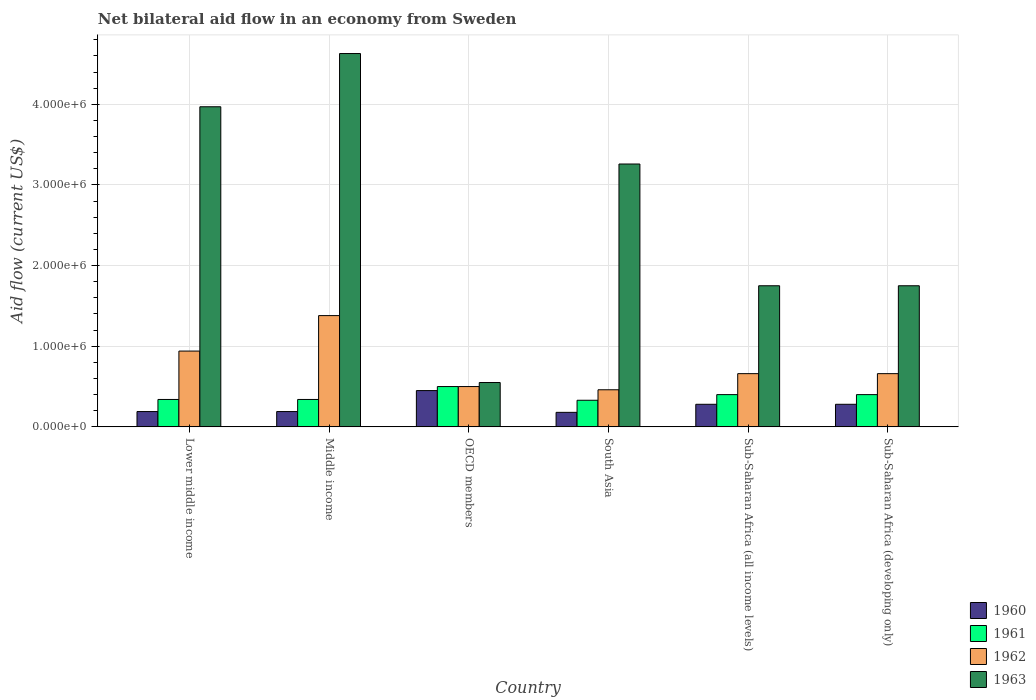How many different coloured bars are there?
Ensure brevity in your answer.  4. How many groups of bars are there?
Ensure brevity in your answer.  6. How many bars are there on the 2nd tick from the left?
Offer a terse response. 4. How many bars are there on the 3rd tick from the right?
Your answer should be compact. 4. What is the label of the 5th group of bars from the left?
Your answer should be compact. Sub-Saharan Africa (all income levels). Across all countries, what is the maximum net bilateral aid flow in 1961?
Make the answer very short. 5.00e+05. In which country was the net bilateral aid flow in 1960 maximum?
Your answer should be very brief. OECD members. What is the total net bilateral aid flow in 1963 in the graph?
Give a very brief answer. 1.59e+07. What is the difference between the net bilateral aid flow in 1962 in South Asia and that in Sub-Saharan Africa (developing only)?
Keep it short and to the point. -2.00e+05. What is the difference between the net bilateral aid flow in 1960 in Sub-Saharan Africa (developing only) and the net bilateral aid flow in 1961 in South Asia?
Ensure brevity in your answer.  -5.00e+04. What is the average net bilateral aid flow in 1962 per country?
Provide a short and direct response. 7.67e+05. What is the difference between the net bilateral aid flow of/in 1963 and net bilateral aid flow of/in 1962 in Sub-Saharan Africa (developing only)?
Keep it short and to the point. 1.09e+06. In how many countries, is the net bilateral aid flow in 1963 greater than 4200000 US$?
Give a very brief answer. 1. What is the ratio of the net bilateral aid flow in 1963 in South Asia to that in Sub-Saharan Africa (developing only)?
Your answer should be very brief. 1.86. Is the net bilateral aid flow in 1960 in Lower middle income less than that in Sub-Saharan Africa (developing only)?
Give a very brief answer. Yes. Is the difference between the net bilateral aid flow in 1963 in South Asia and Sub-Saharan Africa (developing only) greater than the difference between the net bilateral aid flow in 1962 in South Asia and Sub-Saharan Africa (developing only)?
Give a very brief answer. Yes. What is the difference between the highest and the second highest net bilateral aid flow in 1960?
Keep it short and to the point. 1.70e+05. What does the 3rd bar from the left in Lower middle income represents?
Your answer should be compact. 1962. Is it the case that in every country, the sum of the net bilateral aid flow in 1960 and net bilateral aid flow in 1963 is greater than the net bilateral aid flow in 1962?
Offer a terse response. Yes. How many bars are there?
Ensure brevity in your answer.  24. Are all the bars in the graph horizontal?
Ensure brevity in your answer.  No. Does the graph contain any zero values?
Your answer should be very brief. No. Does the graph contain grids?
Your answer should be very brief. Yes. How are the legend labels stacked?
Give a very brief answer. Vertical. What is the title of the graph?
Provide a succinct answer. Net bilateral aid flow in an economy from Sweden. Does "1982" appear as one of the legend labels in the graph?
Give a very brief answer. No. What is the Aid flow (current US$) in 1962 in Lower middle income?
Give a very brief answer. 9.40e+05. What is the Aid flow (current US$) in 1963 in Lower middle income?
Offer a terse response. 3.97e+06. What is the Aid flow (current US$) of 1960 in Middle income?
Provide a succinct answer. 1.90e+05. What is the Aid flow (current US$) in 1962 in Middle income?
Ensure brevity in your answer.  1.38e+06. What is the Aid flow (current US$) of 1963 in Middle income?
Provide a short and direct response. 4.63e+06. What is the Aid flow (current US$) of 1960 in OECD members?
Your answer should be compact. 4.50e+05. What is the Aid flow (current US$) in 1961 in OECD members?
Your response must be concise. 5.00e+05. What is the Aid flow (current US$) of 1963 in OECD members?
Your answer should be compact. 5.50e+05. What is the Aid flow (current US$) in 1960 in South Asia?
Your answer should be very brief. 1.80e+05. What is the Aid flow (current US$) in 1963 in South Asia?
Offer a terse response. 3.26e+06. What is the Aid flow (current US$) of 1962 in Sub-Saharan Africa (all income levels)?
Offer a very short reply. 6.60e+05. What is the Aid flow (current US$) of 1963 in Sub-Saharan Africa (all income levels)?
Give a very brief answer. 1.75e+06. What is the Aid flow (current US$) of 1961 in Sub-Saharan Africa (developing only)?
Ensure brevity in your answer.  4.00e+05. What is the Aid flow (current US$) of 1963 in Sub-Saharan Africa (developing only)?
Provide a succinct answer. 1.75e+06. Across all countries, what is the maximum Aid flow (current US$) of 1962?
Offer a terse response. 1.38e+06. Across all countries, what is the maximum Aid flow (current US$) in 1963?
Keep it short and to the point. 4.63e+06. Across all countries, what is the minimum Aid flow (current US$) in 1963?
Ensure brevity in your answer.  5.50e+05. What is the total Aid flow (current US$) of 1960 in the graph?
Provide a short and direct response. 1.57e+06. What is the total Aid flow (current US$) of 1961 in the graph?
Give a very brief answer. 2.31e+06. What is the total Aid flow (current US$) in 1962 in the graph?
Your answer should be compact. 4.60e+06. What is the total Aid flow (current US$) of 1963 in the graph?
Give a very brief answer. 1.59e+07. What is the difference between the Aid flow (current US$) of 1962 in Lower middle income and that in Middle income?
Give a very brief answer. -4.40e+05. What is the difference between the Aid flow (current US$) in 1963 in Lower middle income and that in Middle income?
Ensure brevity in your answer.  -6.60e+05. What is the difference between the Aid flow (current US$) of 1963 in Lower middle income and that in OECD members?
Provide a succinct answer. 3.42e+06. What is the difference between the Aid flow (current US$) in 1962 in Lower middle income and that in South Asia?
Provide a short and direct response. 4.80e+05. What is the difference between the Aid flow (current US$) of 1963 in Lower middle income and that in South Asia?
Give a very brief answer. 7.10e+05. What is the difference between the Aid flow (current US$) of 1961 in Lower middle income and that in Sub-Saharan Africa (all income levels)?
Your answer should be very brief. -6.00e+04. What is the difference between the Aid flow (current US$) in 1963 in Lower middle income and that in Sub-Saharan Africa (all income levels)?
Offer a terse response. 2.22e+06. What is the difference between the Aid flow (current US$) in 1960 in Lower middle income and that in Sub-Saharan Africa (developing only)?
Ensure brevity in your answer.  -9.00e+04. What is the difference between the Aid flow (current US$) of 1963 in Lower middle income and that in Sub-Saharan Africa (developing only)?
Ensure brevity in your answer.  2.22e+06. What is the difference between the Aid flow (current US$) in 1961 in Middle income and that in OECD members?
Ensure brevity in your answer.  -1.60e+05. What is the difference between the Aid flow (current US$) in 1962 in Middle income and that in OECD members?
Your response must be concise. 8.80e+05. What is the difference between the Aid flow (current US$) of 1963 in Middle income and that in OECD members?
Keep it short and to the point. 4.08e+06. What is the difference between the Aid flow (current US$) in 1962 in Middle income and that in South Asia?
Make the answer very short. 9.20e+05. What is the difference between the Aid flow (current US$) in 1963 in Middle income and that in South Asia?
Offer a very short reply. 1.37e+06. What is the difference between the Aid flow (current US$) in 1960 in Middle income and that in Sub-Saharan Africa (all income levels)?
Give a very brief answer. -9.00e+04. What is the difference between the Aid flow (current US$) of 1962 in Middle income and that in Sub-Saharan Africa (all income levels)?
Ensure brevity in your answer.  7.20e+05. What is the difference between the Aid flow (current US$) of 1963 in Middle income and that in Sub-Saharan Africa (all income levels)?
Your answer should be compact. 2.88e+06. What is the difference between the Aid flow (current US$) of 1960 in Middle income and that in Sub-Saharan Africa (developing only)?
Your answer should be very brief. -9.00e+04. What is the difference between the Aid flow (current US$) in 1961 in Middle income and that in Sub-Saharan Africa (developing only)?
Your answer should be compact. -6.00e+04. What is the difference between the Aid flow (current US$) of 1962 in Middle income and that in Sub-Saharan Africa (developing only)?
Keep it short and to the point. 7.20e+05. What is the difference between the Aid flow (current US$) of 1963 in Middle income and that in Sub-Saharan Africa (developing only)?
Provide a short and direct response. 2.88e+06. What is the difference between the Aid flow (current US$) in 1960 in OECD members and that in South Asia?
Keep it short and to the point. 2.70e+05. What is the difference between the Aid flow (current US$) of 1962 in OECD members and that in South Asia?
Your answer should be compact. 4.00e+04. What is the difference between the Aid flow (current US$) of 1963 in OECD members and that in South Asia?
Keep it short and to the point. -2.71e+06. What is the difference between the Aid flow (current US$) in 1961 in OECD members and that in Sub-Saharan Africa (all income levels)?
Provide a short and direct response. 1.00e+05. What is the difference between the Aid flow (current US$) in 1962 in OECD members and that in Sub-Saharan Africa (all income levels)?
Offer a terse response. -1.60e+05. What is the difference between the Aid flow (current US$) in 1963 in OECD members and that in Sub-Saharan Africa (all income levels)?
Ensure brevity in your answer.  -1.20e+06. What is the difference between the Aid flow (current US$) in 1960 in OECD members and that in Sub-Saharan Africa (developing only)?
Keep it short and to the point. 1.70e+05. What is the difference between the Aid flow (current US$) in 1962 in OECD members and that in Sub-Saharan Africa (developing only)?
Make the answer very short. -1.60e+05. What is the difference between the Aid flow (current US$) in 1963 in OECD members and that in Sub-Saharan Africa (developing only)?
Make the answer very short. -1.20e+06. What is the difference between the Aid flow (current US$) in 1961 in South Asia and that in Sub-Saharan Africa (all income levels)?
Offer a very short reply. -7.00e+04. What is the difference between the Aid flow (current US$) in 1962 in South Asia and that in Sub-Saharan Africa (all income levels)?
Ensure brevity in your answer.  -2.00e+05. What is the difference between the Aid flow (current US$) of 1963 in South Asia and that in Sub-Saharan Africa (all income levels)?
Give a very brief answer. 1.51e+06. What is the difference between the Aid flow (current US$) of 1960 in South Asia and that in Sub-Saharan Africa (developing only)?
Provide a short and direct response. -1.00e+05. What is the difference between the Aid flow (current US$) in 1961 in South Asia and that in Sub-Saharan Africa (developing only)?
Ensure brevity in your answer.  -7.00e+04. What is the difference between the Aid flow (current US$) in 1963 in South Asia and that in Sub-Saharan Africa (developing only)?
Your answer should be very brief. 1.51e+06. What is the difference between the Aid flow (current US$) of 1960 in Sub-Saharan Africa (all income levels) and that in Sub-Saharan Africa (developing only)?
Provide a short and direct response. 0. What is the difference between the Aid flow (current US$) of 1962 in Sub-Saharan Africa (all income levels) and that in Sub-Saharan Africa (developing only)?
Offer a terse response. 0. What is the difference between the Aid flow (current US$) in 1963 in Sub-Saharan Africa (all income levels) and that in Sub-Saharan Africa (developing only)?
Ensure brevity in your answer.  0. What is the difference between the Aid flow (current US$) in 1960 in Lower middle income and the Aid flow (current US$) in 1962 in Middle income?
Your answer should be compact. -1.19e+06. What is the difference between the Aid flow (current US$) in 1960 in Lower middle income and the Aid flow (current US$) in 1963 in Middle income?
Provide a short and direct response. -4.44e+06. What is the difference between the Aid flow (current US$) of 1961 in Lower middle income and the Aid flow (current US$) of 1962 in Middle income?
Make the answer very short. -1.04e+06. What is the difference between the Aid flow (current US$) in 1961 in Lower middle income and the Aid flow (current US$) in 1963 in Middle income?
Offer a terse response. -4.29e+06. What is the difference between the Aid flow (current US$) of 1962 in Lower middle income and the Aid flow (current US$) of 1963 in Middle income?
Provide a short and direct response. -3.69e+06. What is the difference between the Aid flow (current US$) in 1960 in Lower middle income and the Aid flow (current US$) in 1961 in OECD members?
Provide a succinct answer. -3.10e+05. What is the difference between the Aid flow (current US$) in 1960 in Lower middle income and the Aid flow (current US$) in 1962 in OECD members?
Make the answer very short. -3.10e+05. What is the difference between the Aid flow (current US$) in 1960 in Lower middle income and the Aid flow (current US$) in 1963 in OECD members?
Your answer should be compact. -3.60e+05. What is the difference between the Aid flow (current US$) of 1961 in Lower middle income and the Aid flow (current US$) of 1962 in OECD members?
Give a very brief answer. -1.60e+05. What is the difference between the Aid flow (current US$) of 1962 in Lower middle income and the Aid flow (current US$) of 1963 in OECD members?
Your answer should be very brief. 3.90e+05. What is the difference between the Aid flow (current US$) of 1960 in Lower middle income and the Aid flow (current US$) of 1961 in South Asia?
Make the answer very short. -1.40e+05. What is the difference between the Aid flow (current US$) in 1960 in Lower middle income and the Aid flow (current US$) in 1963 in South Asia?
Your response must be concise. -3.07e+06. What is the difference between the Aid flow (current US$) of 1961 in Lower middle income and the Aid flow (current US$) of 1962 in South Asia?
Provide a succinct answer. -1.20e+05. What is the difference between the Aid flow (current US$) in 1961 in Lower middle income and the Aid flow (current US$) in 1963 in South Asia?
Make the answer very short. -2.92e+06. What is the difference between the Aid flow (current US$) in 1962 in Lower middle income and the Aid flow (current US$) in 1963 in South Asia?
Your answer should be very brief. -2.32e+06. What is the difference between the Aid flow (current US$) of 1960 in Lower middle income and the Aid flow (current US$) of 1961 in Sub-Saharan Africa (all income levels)?
Offer a terse response. -2.10e+05. What is the difference between the Aid flow (current US$) in 1960 in Lower middle income and the Aid flow (current US$) in 1962 in Sub-Saharan Africa (all income levels)?
Provide a succinct answer. -4.70e+05. What is the difference between the Aid flow (current US$) of 1960 in Lower middle income and the Aid flow (current US$) of 1963 in Sub-Saharan Africa (all income levels)?
Give a very brief answer. -1.56e+06. What is the difference between the Aid flow (current US$) in 1961 in Lower middle income and the Aid flow (current US$) in 1962 in Sub-Saharan Africa (all income levels)?
Your answer should be very brief. -3.20e+05. What is the difference between the Aid flow (current US$) in 1961 in Lower middle income and the Aid flow (current US$) in 1963 in Sub-Saharan Africa (all income levels)?
Your answer should be compact. -1.41e+06. What is the difference between the Aid flow (current US$) in 1962 in Lower middle income and the Aid flow (current US$) in 1963 in Sub-Saharan Africa (all income levels)?
Keep it short and to the point. -8.10e+05. What is the difference between the Aid flow (current US$) of 1960 in Lower middle income and the Aid flow (current US$) of 1961 in Sub-Saharan Africa (developing only)?
Ensure brevity in your answer.  -2.10e+05. What is the difference between the Aid flow (current US$) in 1960 in Lower middle income and the Aid flow (current US$) in 1962 in Sub-Saharan Africa (developing only)?
Offer a terse response. -4.70e+05. What is the difference between the Aid flow (current US$) of 1960 in Lower middle income and the Aid flow (current US$) of 1963 in Sub-Saharan Africa (developing only)?
Ensure brevity in your answer.  -1.56e+06. What is the difference between the Aid flow (current US$) of 1961 in Lower middle income and the Aid flow (current US$) of 1962 in Sub-Saharan Africa (developing only)?
Offer a terse response. -3.20e+05. What is the difference between the Aid flow (current US$) of 1961 in Lower middle income and the Aid flow (current US$) of 1963 in Sub-Saharan Africa (developing only)?
Offer a terse response. -1.41e+06. What is the difference between the Aid flow (current US$) in 1962 in Lower middle income and the Aid flow (current US$) in 1963 in Sub-Saharan Africa (developing only)?
Ensure brevity in your answer.  -8.10e+05. What is the difference between the Aid flow (current US$) in 1960 in Middle income and the Aid flow (current US$) in 1961 in OECD members?
Give a very brief answer. -3.10e+05. What is the difference between the Aid flow (current US$) of 1960 in Middle income and the Aid flow (current US$) of 1962 in OECD members?
Your response must be concise. -3.10e+05. What is the difference between the Aid flow (current US$) in 1960 in Middle income and the Aid flow (current US$) in 1963 in OECD members?
Your answer should be very brief. -3.60e+05. What is the difference between the Aid flow (current US$) of 1961 in Middle income and the Aid flow (current US$) of 1962 in OECD members?
Your answer should be compact. -1.60e+05. What is the difference between the Aid flow (current US$) of 1962 in Middle income and the Aid flow (current US$) of 1963 in OECD members?
Give a very brief answer. 8.30e+05. What is the difference between the Aid flow (current US$) in 1960 in Middle income and the Aid flow (current US$) in 1963 in South Asia?
Your answer should be compact. -3.07e+06. What is the difference between the Aid flow (current US$) in 1961 in Middle income and the Aid flow (current US$) in 1962 in South Asia?
Offer a terse response. -1.20e+05. What is the difference between the Aid flow (current US$) of 1961 in Middle income and the Aid flow (current US$) of 1963 in South Asia?
Provide a short and direct response. -2.92e+06. What is the difference between the Aid flow (current US$) of 1962 in Middle income and the Aid flow (current US$) of 1963 in South Asia?
Offer a terse response. -1.88e+06. What is the difference between the Aid flow (current US$) in 1960 in Middle income and the Aid flow (current US$) in 1962 in Sub-Saharan Africa (all income levels)?
Give a very brief answer. -4.70e+05. What is the difference between the Aid flow (current US$) in 1960 in Middle income and the Aid flow (current US$) in 1963 in Sub-Saharan Africa (all income levels)?
Your answer should be very brief. -1.56e+06. What is the difference between the Aid flow (current US$) of 1961 in Middle income and the Aid flow (current US$) of 1962 in Sub-Saharan Africa (all income levels)?
Offer a very short reply. -3.20e+05. What is the difference between the Aid flow (current US$) in 1961 in Middle income and the Aid flow (current US$) in 1963 in Sub-Saharan Africa (all income levels)?
Ensure brevity in your answer.  -1.41e+06. What is the difference between the Aid flow (current US$) in 1962 in Middle income and the Aid flow (current US$) in 1963 in Sub-Saharan Africa (all income levels)?
Give a very brief answer. -3.70e+05. What is the difference between the Aid flow (current US$) of 1960 in Middle income and the Aid flow (current US$) of 1962 in Sub-Saharan Africa (developing only)?
Offer a very short reply. -4.70e+05. What is the difference between the Aid flow (current US$) of 1960 in Middle income and the Aid flow (current US$) of 1963 in Sub-Saharan Africa (developing only)?
Offer a terse response. -1.56e+06. What is the difference between the Aid flow (current US$) of 1961 in Middle income and the Aid flow (current US$) of 1962 in Sub-Saharan Africa (developing only)?
Offer a very short reply. -3.20e+05. What is the difference between the Aid flow (current US$) of 1961 in Middle income and the Aid flow (current US$) of 1963 in Sub-Saharan Africa (developing only)?
Make the answer very short. -1.41e+06. What is the difference between the Aid flow (current US$) in 1962 in Middle income and the Aid flow (current US$) in 1963 in Sub-Saharan Africa (developing only)?
Offer a terse response. -3.70e+05. What is the difference between the Aid flow (current US$) of 1960 in OECD members and the Aid flow (current US$) of 1962 in South Asia?
Give a very brief answer. -10000. What is the difference between the Aid flow (current US$) of 1960 in OECD members and the Aid flow (current US$) of 1963 in South Asia?
Make the answer very short. -2.81e+06. What is the difference between the Aid flow (current US$) in 1961 in OECD members and the Aid flow (current US$) in 1962 in South Asia?
Ensure brevity in your answer.  4.00e+04. What is the difference between the Aid flow (current US$) in 1961 in OECD members and the Aid flow (current US$) in 1963 in South Asia?
Make the answer very short. -2.76e+06. What is the difference between the Aid flow (current US$) of 1962 in OECD members and the Aid flow (current US$) of 1963 in South Asia?
Give a very brief answer. -2.76e+06. What is the difference between the Aid flow (current US$) of 1960 in OECD members and the Aid flow (current US$) of 1963 in Sub-Saharan Africa (all income levels)?
Provide a succinct answer. -1.30e+06. What is the difference between the Aid flow (current US$) in 1961 in OECD members and the Aid flow (current US$) in 1963 in Sub-Saharan Africa (all income levels)?
Give a very brief answer. -1.25e+06. What is the difference between the Aid flow (current US$) in 1962 in OECD members and the Aid flow (current US$) in 1963 in Sub-Saharan Africa (all income levels)?
Your response must be concise. -1.25e+06. What is the difference between the Aid flow (current US$) in 1960 in OECD members and the Aid flow (current US$) in 1963 in Sub-Saharan Africa (developing only)?
Make the answer very short. -1.30e+06. What is the difference between the Aid flow (current US$) in 1961 in OECD members and the Aid flow (current US$) in 1962 in Sub-Saharan Africa (developing only)?
Your response must be concise. -1.60e+05. What is the difference between the Aid flow (current US$) of 1961 in OECD members and the Aid flow (current US$) of 1963 in Sub-Saharan Africa (developing only)?
Ensure brevity in your answer.  -1.25e+06. What is the difference between the Aid flow (current US$) in 1962 in OECD members and the Aid flow (current US$) in 1963 in Sub-Saharan Africa (developing only)?
Ensure brevity in your answer.  -1.25e+06. What is the difference between the Aid flow (current US$) of 1960 in South Asia and the Aid flow (current US$) of 1962 in Sub-Saharan Africa (all income levels)?
Your answer should be compact. -4.80e+05. What is the difference between the Aid flow (current US$) in 1960 in South Asia and the Aid flow (current US$) in 1963 in Sub-Saharan Africa (all income levels)?
Provide a succinct answer. -1.57e+06. What is the difference between the Aid flow (current US$) in 1961 in South Asia and the Aid flow (current US$) in 1962 in Sub-Saharan Africa (all income levels)?
Offer a very short reply. -3.30e+05. What is the difference between the Aid flow (current US$) in 1961 in South Asia and the Aid flow (current US$) in 1963 in Sub-Saharan Africa (all income levels)?
Give a very brief answer. -1.42e+06. What is the difference between the Aid flow (current US$) of 1962 in South Asia and the Aid flow (current US$) of 1963 in Sub-Saharan Africa (all income levels)?
Keep it short and to the point. -1.29e+06. What is the difference between the Aid flow (current US$) of 1960 in South Asia and the Aid flow (current US$) of 1961 in Sub-Saharan Africa (developing only)?
Provide a succinct answer. -2.20e+05. What is the difference between the Aid flow (current US$) in 1960 in South Asia and the Aid flow (current US$) in 1962 in Sub-Saharan Africa (developing only)?
Your response must be concise. -4.80e+05. What is the difference between the Aid flow (current US$) of 1960 in South Asia and the Aid flow (current US$) of 1963 in Sub-Saharan Africa (developing only)?
Offer a very short reply. -1.57e+06. What is the difference between the Aid flow (current US$) in 1961 in South Asia and the Aid flow (current US$) in 1962 in Sub-Saharan Africa (developing only)?
Make the answer very short. -3.30e+05. What is the difference between the Aid flow (current US$) in 1961 in South Asia and the Aid flow (current US$) in 1963 in Sub-Saharan Africa (developing only)?
Provide a short and direct response. -1.42e+06. What is the difference between the Aid flow (current US$) of 1962 in South Asia and the Aid flow (current US$) of 1963 in Sub-Saharan Africa (developing only)?
Offer a terse response. -1.29e+06. What is the difference between the Aid flow (current US$) of 1960 in Sub-Saharan Africa (all income levels) and the Aid flow (current US$) of 1962 in Sub-Saharan Africa (developing only)?
Provide a succinct answer. -3.80e+05. What is the difference between the Aid flow (current US$) of 1960 in Sub-Saharan Africa (all income levels) and the Aid flow (current US$) of 1963 in Sub-Saharan Africa (developing only)?
Offer a terse response. -1.47e+06. What is the difference between the Aid flow (current US$) of 1961 in Sub-Saharan Africa (all income levels) and the Aid flow (current US$) of 1963 in Sub-Saharan Africa (developing only)?
Your response must be concise. -1.35e+06. What is the difference between the Aid flow (current US$) of 1962 in Sub-Saharan Africa (all income levels) and the Aid flow (current US$) of 1963 in Sub-Saharan Africa (developing only)?
Ensure brevity in your answer.  -1.09e+06. What is the average Aid flow (current US$) of 1960 per country?
Ensure brevity in your answer.  2.62e+05. What is the average Aid flow (current US$) of 1961 per country?
Your answer should be very brief. 3.85e+05. What is the average Aid flow (current US$) of 1962 per country?
Offer a terse response. 7.67e+05. What is the average Aid flow (current US$) in 1963 per country?
Offer a very short reply. 2.65e+06. What is the difference between the Aid flow (current US$) of 1960 and Aid flow (current US$) of 1962 in Lower middle income?
Make the answer very short. -7.50e+05. What is the difference between the Aid flow (current US$) in 1960 and Aid flow (current US$) in 1963 in Lower middle income?
Your answer should be very brief. -3.78e+06. What is the difference between the Aid flow (current US$) of 1961 and Aid flow (current US$) of 1962 in Lower middle income?
Offer a terse response. -6.00e+05. What is the difference between the Aid flow (current US$) in 1961 and Aid flow (current US$) in 1963 in Lower middle income?
Make the answer very short. -3.63e+06. What is the difference between the Aid flow (current US$) of 1962 and Aid flow (current US$) of 1963 in Lower middle income?
Ensure brevity in your answer.  -3.03e+06. What is the difference between the Aid flow (current US$) in 1960 and Aid flow (current US$) in 1961 in Middle income?
Offer a very short reply. -1.50e+05. What is the difference between the Aid flow (current US$) in 1960 and Aid flow (current US$) in 1962 in Middle income?
Your answer should be compact. -1.19e+06. What is the difference between the Aid flow (current US$) of 1960 and Aid flow (current US$) of 1963 in Middle income?
Provide a short and direct response. -4.44e+06. What is the difference between the Aid flow (current US$) in 1961 and Aid flow (current US$) in 1962 in Middle income?
Ensure brevity in your answer.  -1.04e+06. What is the difference between the Aid flow (current US$) of 1961 and Aid flow (current US$) of 1963 in Middle income?
Your answer should be compact. -4.29e+06. What is the difference between the Aid flow (current US$) in 1962 and Aid flow (current US$) in 1963 in Middle income?
Offer a terse response. -3.25e+06. What is the difference between the Aid flow (current US$) of 1960 and Aid flow (current US$) of 1962 in OECD members?
Provide a short and direct response. -5.00e+04. What is the difference between the Aid flow (current US$) in 1960 and Aid flow (current US$) in 1963 in OECD members?
Offer a terse response. -1.00e+05. What is the difference between the Aid flow (current US$) of 1960 and Aid flow (current US$) of 1962 in South Asia?
Provide a short and direct response. -2.80e+05. What is the difference between the Aid flow (current US$) of 1960 and Aid flow (current US$) of 1963 in South Asia?
Offer a terse response. -3.08e+06. What is the difference between the Aid flow (current US$) in 1961 and Aid flow (current US$) in 1962 in South Asia?
Keep it short and to the point. -1.30e+05. What is the difference between the Aid flow (current US$) of 1961 and Aid flow (current US$) of 1963 in South Asia?
Your answer should be compact. -2.93e+06. What is the difference between the Aid flow (current US$) in 1962 and Aid flow (current US$) in 1963 in South Asia?
Your answer should be compact. -2.80e+06. What is the difference between the Aid flow (current US$) in 1960 and Aid flow (current US$) in 1962 in Sub-Saharan Africa (all income levels)?
Give a very brief answer. -3.80e+05. What is the difference between the Aid flow (current US$) of 1960 and Aid flow (current US$) of 1963 in Sub-Saharan Africa (all income levels)?
Give a very brief answer. -1.47e+06. What is the difference between the Aid flow (current US$) in 1961 and Aid flow (current US$) in 1962 in Sub-Saharan Africa (all income levels)?
Offer a terse response. -2.60e+05. What is the difference between the Aid flow (current US$) in 1961 and Aid flow (current US$) in 1963 in Sub-Saharan Africa (all income levels)?
Offer a very short reply. -1.35e+06. What is the difference between the Aid flow (current US$) of 1962 and Aid flow (current US$) of 1963 in Sub-Saharan Africa (all income levels)?
Make the answer very short. -1.09e+06. What is the difference between the Aid flow (current US$) of 1960 and Aid flow (current US$) of 1962 in Sub-Saharan Africa (developing only)?
Keep it short and to the point. -3.80e+05. What is the difference between the Aid flow (current US$) of 1960 and Aid flow (current US$) of 1963 in Sub-Saharan Africa (developing only)?
Your answer should be compact. -1.47e+06. What is the difference between the Aid flow (current US$) of 1961 and Aid flow (current US$) of 1963 in Sub-Saharan Africa (developing only)?
Offer a terse response. -1.35e+06. What is the difference between the Aid flow (current US$) of 1962 and Aid flow (current US$) of 1963 in Sub-Saharan Africa (developing only)?
Provide a short and direct response. -1.09e+06. What is the ratio of the Aid flow (current US$) in 1962 in Lower middle income to that in Middle income?
Provide a short and direct response. 0.68. What is the ratio of the Aid flow (current US$) in 1963 in Lower middle income to that in Middle income?
Provide a short and direct response. 0.86. What is the ratio of the Aid flow (current US$) in 1960 in Lower middle income to that in OECD members?
Ensure brevity in your answer.  0.42. What is the ratio of the Aid flow (current US$) in 1961 in Lower middle income to that in OECD members?
Give a very brief answer. 0.68. What is the ratio of the Aid flow (current US$) of 1962 in Lower middle income to that in OECD members?
Offer a very short reply. 1.88. What is the ratio of the Aid flow (current US$) of 1963 in Lower middle income to that in OECD members?
Offer a very short reply. 7.22. What is the ratio of the Aid flow (current US$) of 1960 in Lower middle income to that in South Asia?
Your answer should be compact. 1.06. What is the ratio of the Aid flow (current US$) of 1961 in Lower middle income to that in South Asia?
Your answer should be compact. 1.03. What is the ratio of the Aid flow (current US$) of 1962 in Lower middle income to that in South Asia?
Offer a very short reply. 2.04. What is the ratio of the Aid flow (current US$) of 1963 in Lower middle income to that in South Asia?
Make the answer very short. 1.22. What is the ratio of the Aid flow (current US$) of 1960 in Lower middle income to that in Sub-Saharan Africa (all income levels)?
Give a very brief answer. 0.68. What is the ratio of the Aid flow (current US$) of 1961 in Lower middle income to that in Sub-Saharan Africa (all income levels)?
Ensure brevity in your answer.  0.85. What is the ratio of the Aid flow (current US$) in 1962 in Lower middle income to that in Sub-Saharan Africa (all income levels)?
Provide a succinct answer. 1.42. What is the ratio of the Aid flow (current US$) in 1963 in Lower middle income to that in Sub-Saharan Africa (all income levels)?
Ensure brevity in your answer.  2.27. What is the ratio of the Aid flow (current US$) of 1960 in Lower middle income to that in Sub-Saharan Africa (developing only)?
Provide a succinct answer. 0.68. What is the ratio of the Aid flow (current US$) of 1961 in Lower middle income to that in Sub-Saharan Africa (developing only)?
Your response must be concise. 0.85. What is the ratio of the Aid flow (current US$) in 1962 in Lower middle income to that in Sub-Saharan Africa (developing only)?
Your response must be concise. 1.42. What is the ratio of the Aid flow (current US$) of 1963 in Lower middle income to that in Sub-Saharan Africa (developing only)?
Provide a succinct answer. 2.27. What is the ratio of the Aid flow (current US$) in 1960 in Middle income to that in OECD members?
Provide a succinct answer. 0.42. What is the ratio of the Aid flow (current US$) of 1961 in Middle income to that in OECD members?
Give a very brief answer. 0.68. What is the ratio of the Aid flow (current US$) of 1962 in Middle income to that in OECD members?
Provide a succinct answer. 2.76. What is the ratio of the Aid flow (current US$) of 1963 in Middle income to that in OECD members?
Keep it short and to the point. 8.42. What is the ratio of the Aid flow (current US$) in 1960 in Middle income to that in South Asia?
Offer a very short reply. 1.06. What is the ratio of the Aid flow (current US$) in 1961 in Middle income to that in South Asia?
Your answer should be very brief. 1.03. What is the ratio of the Aid flow (current US$) in 1963 in Middle income to that in South Asia?
Keep it short and to the point. 1.42. What is the ratio of the Aid flow (current US$) in 1960 in Middle income to that in Sub-Saharan Africa (all income levels)?
Ensure brevity in your answer.  0.68. What is the ratio of the Aid flow (current US$) in 1961 in Middle income to that in Sub-Saharan Africa (all income levels)?
Offer a very short reply. 0.85. What is the ratio of the Aid flow (current US$) of 1962 in Middle income to that in Sub-Saharan Africa (all income levels)?
Offer a terse response. 2.09. What is the ratio of the Aid flow (current US$) in 1963 in Middle income to that in Sub-Saharan Africa (all income levels)?
Provide a succinct answer. 2.65. What is the ratio of the Aid flow (current US$) of 1960 in Middle income to that in Sub-Saharan Africa (developing only)?
Keep it short and to the point. 0.68. What is the ratio of the Aid flow (current US$) in 1962 in Middle income to that in Sub-Saharan Africa (developing only)?
Ensure brevity in your answer.  2.09. What is the ratio of the Aid flow (current US$) in 1963 in Middle income to that in Sub-Saharan Africa (developing only)?
Provide a short and direct response. 2.65. What is the ratio of the Aid flow (current US$) of 1960 in OECD members to that in South Asia?
Keep it short and to the point. 2.5. What is the ratio of the Aid flow (current US$) of 1961 in OECD members to that in South Asia?
Your answer should be very brief. 1.52. What is the ratio of the Aid flow (current US$) in 1962 in OECD members to that in South Asia?
Offer a terse response. 1.09. What is the ratio of the Aid flow (current US$) of 1963 in OECD members to that in South Asia?
Ensure brevity in your answer.  0.17. What is the ratio of the Aid flow (current US$) in 1960 in OECD members to that in Sub-Saharan Africa (all income levels)?
Ensure brevity in your answer.  1.61. What is the ratio of the Aid flow (current US$) in 1961 in OECD members to that in Sub-Saharan Africa (all income levels)?
Your response must be concise. 1.25. What is the ratio of the Aid flow (current US$) of 1962 in OECD members to that in Sub-Saharan Africa (all income levels)?
Give a very brief answer. 0.76. What is the ratio of the Aid flow (current US$) of 1963 in OECD members to that in Sub-Saharan Africa (all income levels)?
Offer a very short reply. 0.31. What is the ratio of the Aid flow (current US$) in 1960 in OECD members to that in Sub-Saharan Africa (developing only)?
Give a very brief answer. 1.61. What is the ratio of the Aid flow (current US$) of 1962 in OECD members to that in Sub-Saharan Africa (developing only)?
Your answer should be compact. 0.76. What is the ratio of the Aid flow (current US$) in 1963 in OECD members to that in Sub-Saharan Africa (developing only)?
Your answer should be compact. 0.31. What is the ratio of the Aid flow (current US$) in 1960 in South Asia to that in Sub-Saharan Africa (all income levels)?
Offer a terse response. 0.64. What is the ratio of the Aid flow (current US$) in 1961 in South Asia to that in Sub-Saharan Africa (all income levels)?
Ensure brevity in your answer.  0.82. What is the ratio of the Aid flow (current US$) of 1962 in South Asia to that in Sub-Saharan Africa (all income levels)?
Offer a very short reply. 0.7. What is the ratio of the Aid flow (current US$) in 1963 in South Asia to that in Sub-Saharan Africa (all income levels)?
Provide a succinct answer. 1.86. What is the ratio of the Aid flow (current US$) of 1960 in South Asia to that in Sub-Saharan Africa (developing only)?
Provide a succinct answer. 0.64. What is the ratio of the Aid flow (current US$) of 1961 in South Asia to that in Sub-Saharan Africa (developing only)?
Your response must be concise. 0.82. What is the ratio of the Aid flow (current US$) of 1962 in South Asia to that in Sub-Saharan Africa (developing only)?
Offer a terse response. 0.7. What is the ratio of the Aid flow (current US$) in 1963 in South Asia to that in Sub-Saharan Africa (developing only)?
Your response must be concise. 1.86. What is the ratio of the Aid flow (current US$) in 1962 in Sub-Saharan Africa (all income levels) to that in Sub-Saharan Africa (developing only)?
Your answer should be very brief. 1. What is the difference between the highest and the second highest Aid flow (current US$) of 1960?
Keep it short and to the point. 1.70e+05. What is the difference between the highest and the lowest Aid flow (current US$) in 1960?
Your answer should be very brief. 2.70e+05. What is the difference between the highest and the lowest Aid flow (current US$) of 1961?
Provide a succinct answer. 1.70e+05. What is the difference between the highest and the lowest Aid flow (current US$) in 1962?
Your response must be concise. 9.20e+05. What is the difference between the highest and the lowest Aid flow (current US$) of 1963?
Keep it short and to the point. 4.08e+06. 